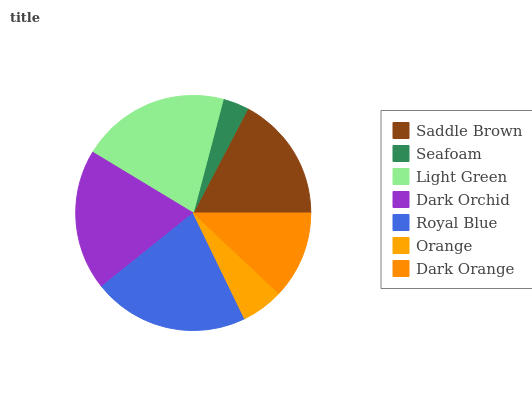Is Seafoam the minimum?
Answer yes or no. Yes. Is Royal Blue the maximum?
Answer yes or no. Yes. Is Light Green the minimum?
Answer yes or no. No. Is Light Green the maximum?
Answer yes or no. No. Is Light Green greater than Seafoam?
Answer yes or no. Yes. Is Seafoam less than Light Green?
Answer yes or no. Yes. Is Seafoam greater than Light Green?
Answer yes or no. No. Is Light Green less than Seafoam?
Answer yes or no. No. Is Saddle Brown the high median?
Answer yes or no. Yes. Is Saddle Brown the low median?
Answer yes or no. Yes. Is Seafoam the high median?
Answer yes or no. No. Is Dark Orange the low median?
Answer yes or no. No. 